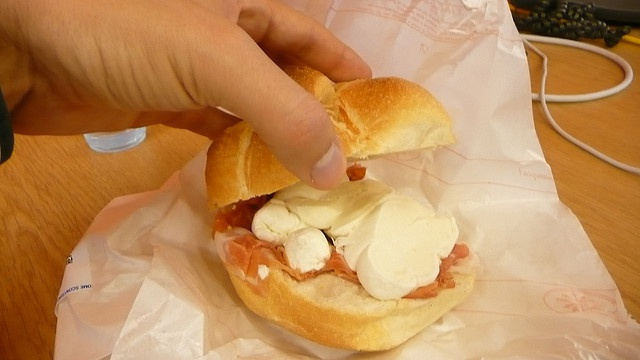Describe the objects in this image and their specific colors. I can see sandwich in brown, tan, red, and orange tones, people in brown, tan, and maroon tones, and bottle in brown, darkgray, tan, gray, and olive tones in this image. 